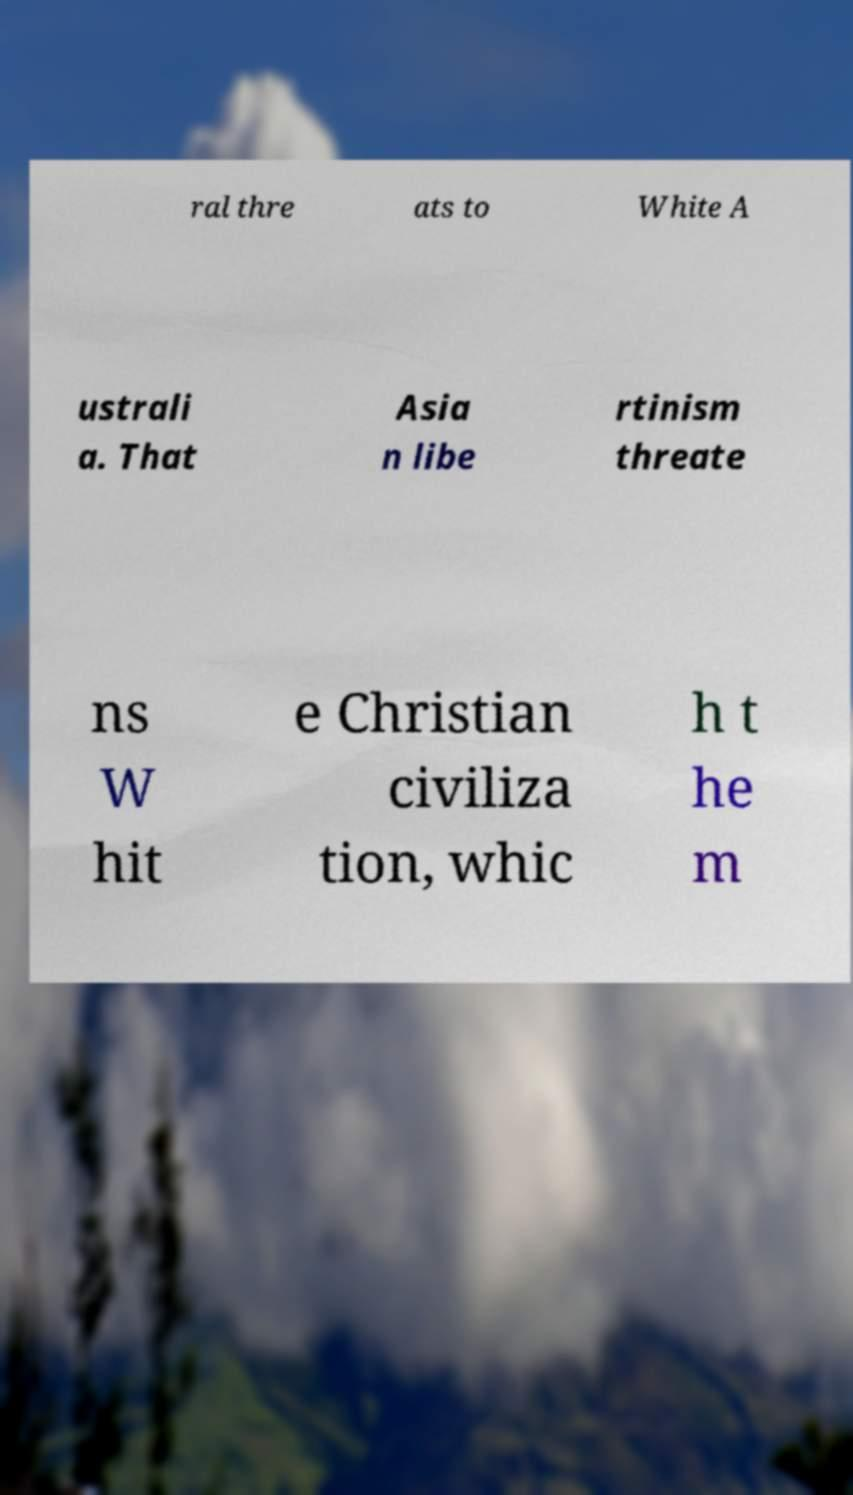Can you read and provide the text displayed in the image?This photo seems to have some interesting text. Can you extract and type it out for me? ral thre ats to White A ustrali a. That Asia n libe rtinism threate ns W hit e Christian civiliza tion, whic h t he m 